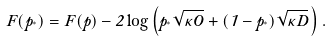<formula> <loc_0><loc_0><loc_500><loc_500>F ( p _ { ^ { * } } ) = F ( p ) - 2 \log \left ( p _ { ^ { * } } \sqrt { \kappa O } + ( 1 - p _ { ^ { * } } ) \sqrt { \kappa D } \, \right ) .</formula> 